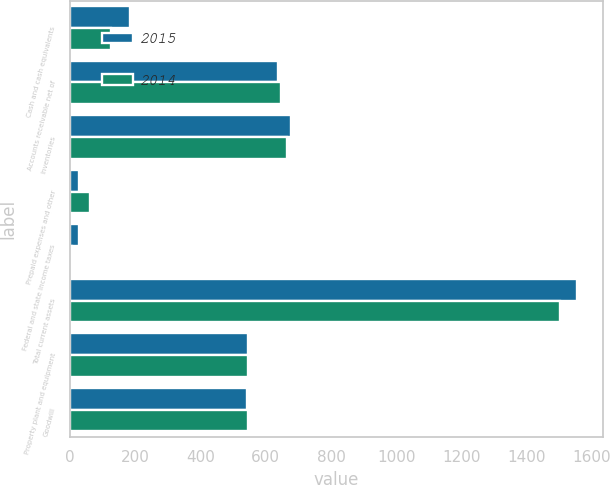Convert chart. <chart><loc_0><loc_0><loc_500><loc_500><stacked_bar_chart><ecel><fcel>Cash and cash equivalents<fcel>Accounts receivable net of<fcel>Inventories<fcel>Prepaid expenses and other<fcel>Federal and state income taxes<fcel>Total current assets<fcel>Property plant and equipment<fcel>Goodwill<nl><fcel>2015<fcel>184.2<fcel>636.5<fcel>676.8<fcel>28.8<fcel>28.2<fcel>1554.5<fcel>545.4<fcel>544<nl><fcel>2014<fcel>124.9<fcel>646.1<fcel>664.9<fcel>61.9<fcel>5.1<fcel>1502.9<fcel>545.4<fcel>546.8<nl></chart> 